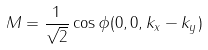<formula> <loc_0><loc_0><loc_500><loc_500>M = \frac { 1 } { \sqrt { 2 } } \cos \phi ( 0 , 0 , k _ { x } - k _ { y } )</formula> 